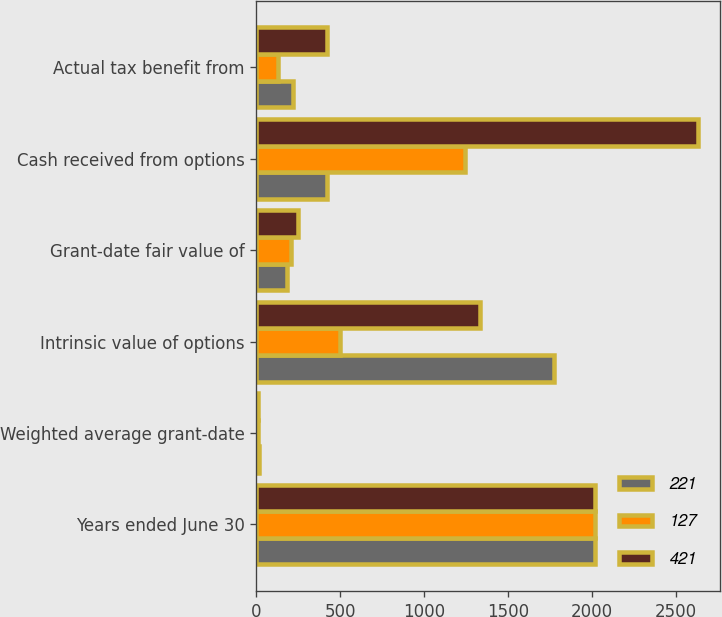Convert chart. <chart><loc_0><loc_0><loc_500><loc_500><stacked_bar_chart><ecel><fcel>Years ended June 30<fcel>Weighted average grant-date<fcel>Intrinsic value of options<fcel>Grant-date fair value of<fcel>Cash received from options<fcel>Actual tax benefit from<nl><fcel>221<fcel>2019<fcel>13.6<fcel>1770<fcel>180<fcel>421<fcel>221<nl><fcel>127<fcel>2018<fcel>11.89<fcel>500<fcel>209<fcel>1245<fcel>127<nl><fcel>421<fcel>2017<fcel>10.45<fcel>1334<fcel>246<fcel>2630<fcel>421<nl></chart> 